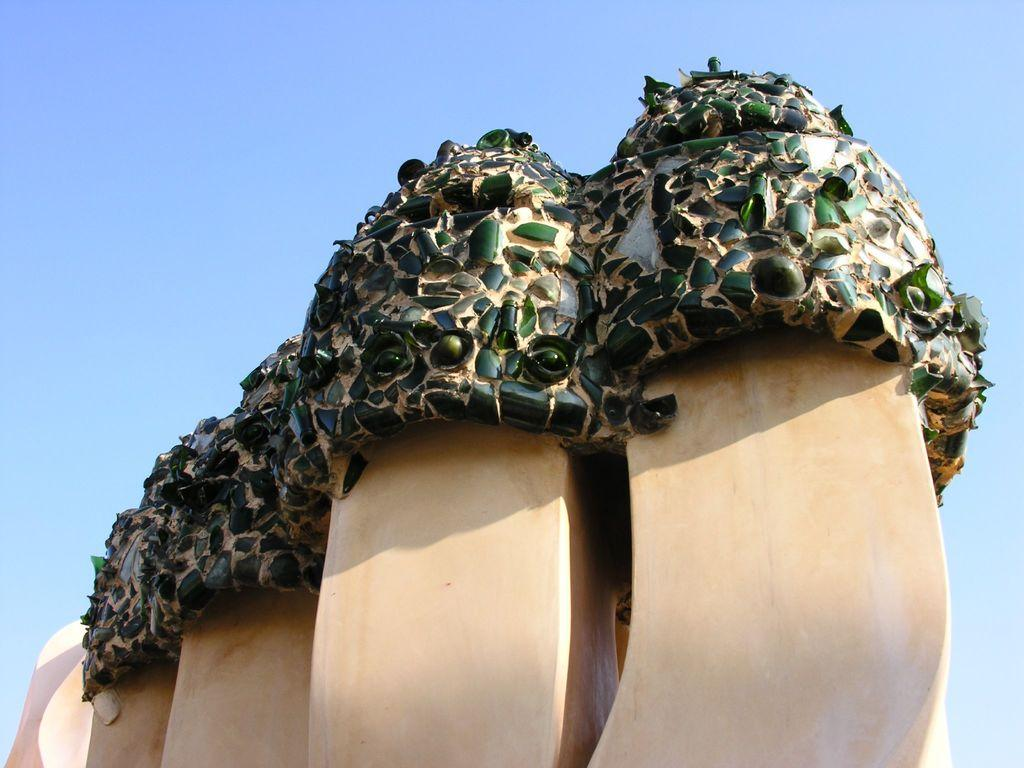What is the main subject in the image? There is a structure in the image. What can be observed about the structure? The structure contains green color bottle pieces. Where is the cactus located in the image? There is no cactus present in the image. What type of bells can be heard ringing in the image? There are no bells present in the image, and therefore no sound can be heard. 